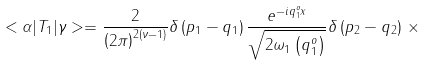Convert formula to latex. <formula><loc_0><loc_0><loc_500><loc_500>< \alpha | T _ { 1 } | \gamma > = \frac { 2 } { \left ( 2 \pi \right ) ^ { 2 \left ( \nu - 1 \right ) } } \delta \left ( p _ { 1 } - q _ { 1 } \right ) \frac { e ^ { - i q _ { 1 } ^ { o } x } } { \sqrt { 2 { \omega } _ { 1 } \left ( q _ { 1 } ^ { o } \right ) } } \delta \left ( p _ { 2 } - q _ { 2 } \right ) \, \times</formula> 